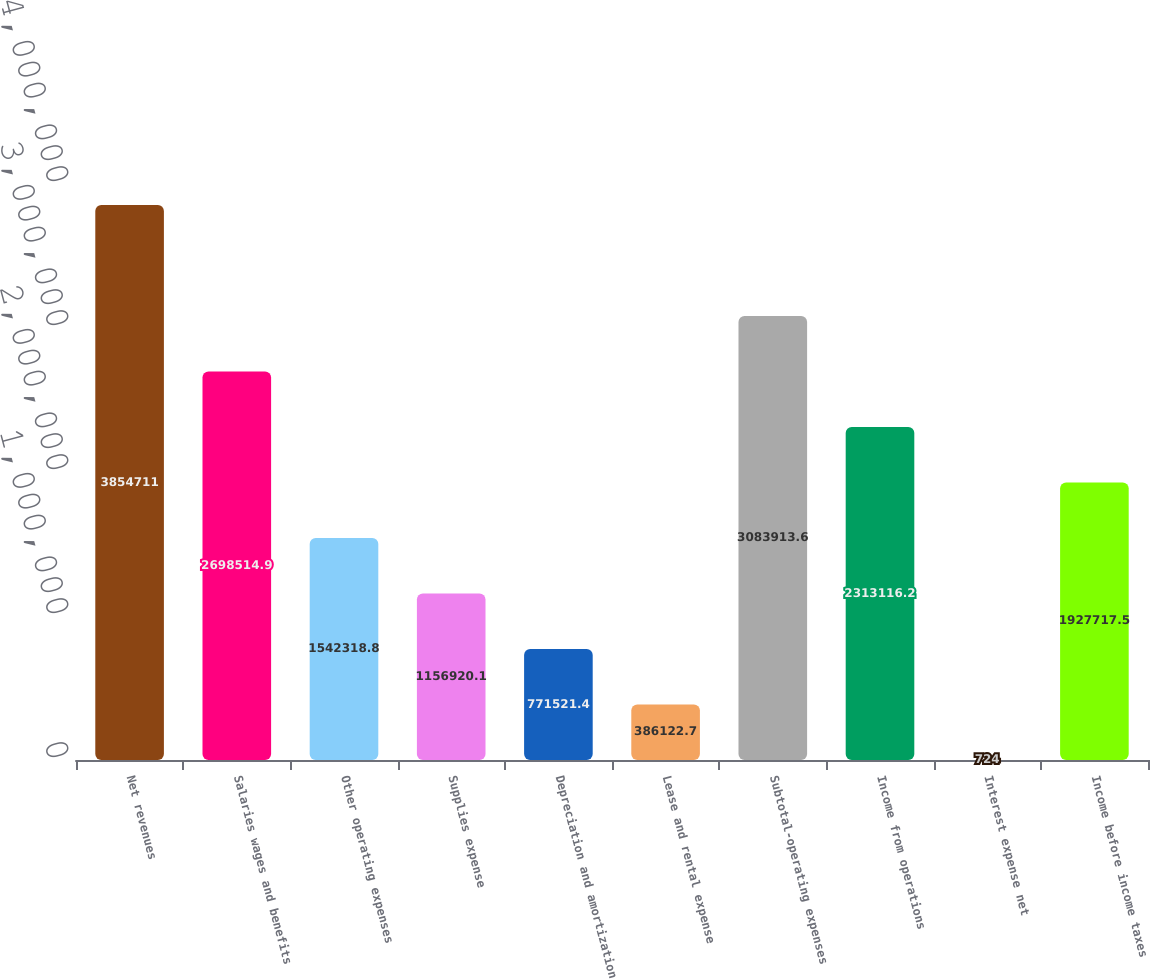<chart> <loc_0><loc_0><loc_500><loc_500><bar_chart><fcel>Net revenues<fcel>Salaries wages and benefits<fcel>Other operating expenses<fcel>Supplies expense<fcel>Depreciation and amortization<fcel>Lease and rental expense<fcel>Subtotal-operating expenses<fcel>Income from operations<fcel>Interest expense net<fcel>Income before income taxes<nl><fcel>3.85471e+06<fcel>2.69851e+06<fcel>1.54232e+06<fcel>1.15692e+06<fcel>771521<fcel>386123<fcel>3.08391e+06<fcel>2.31312e+06<fcel>724<fcel>1.92772e+06<nl></chart> 